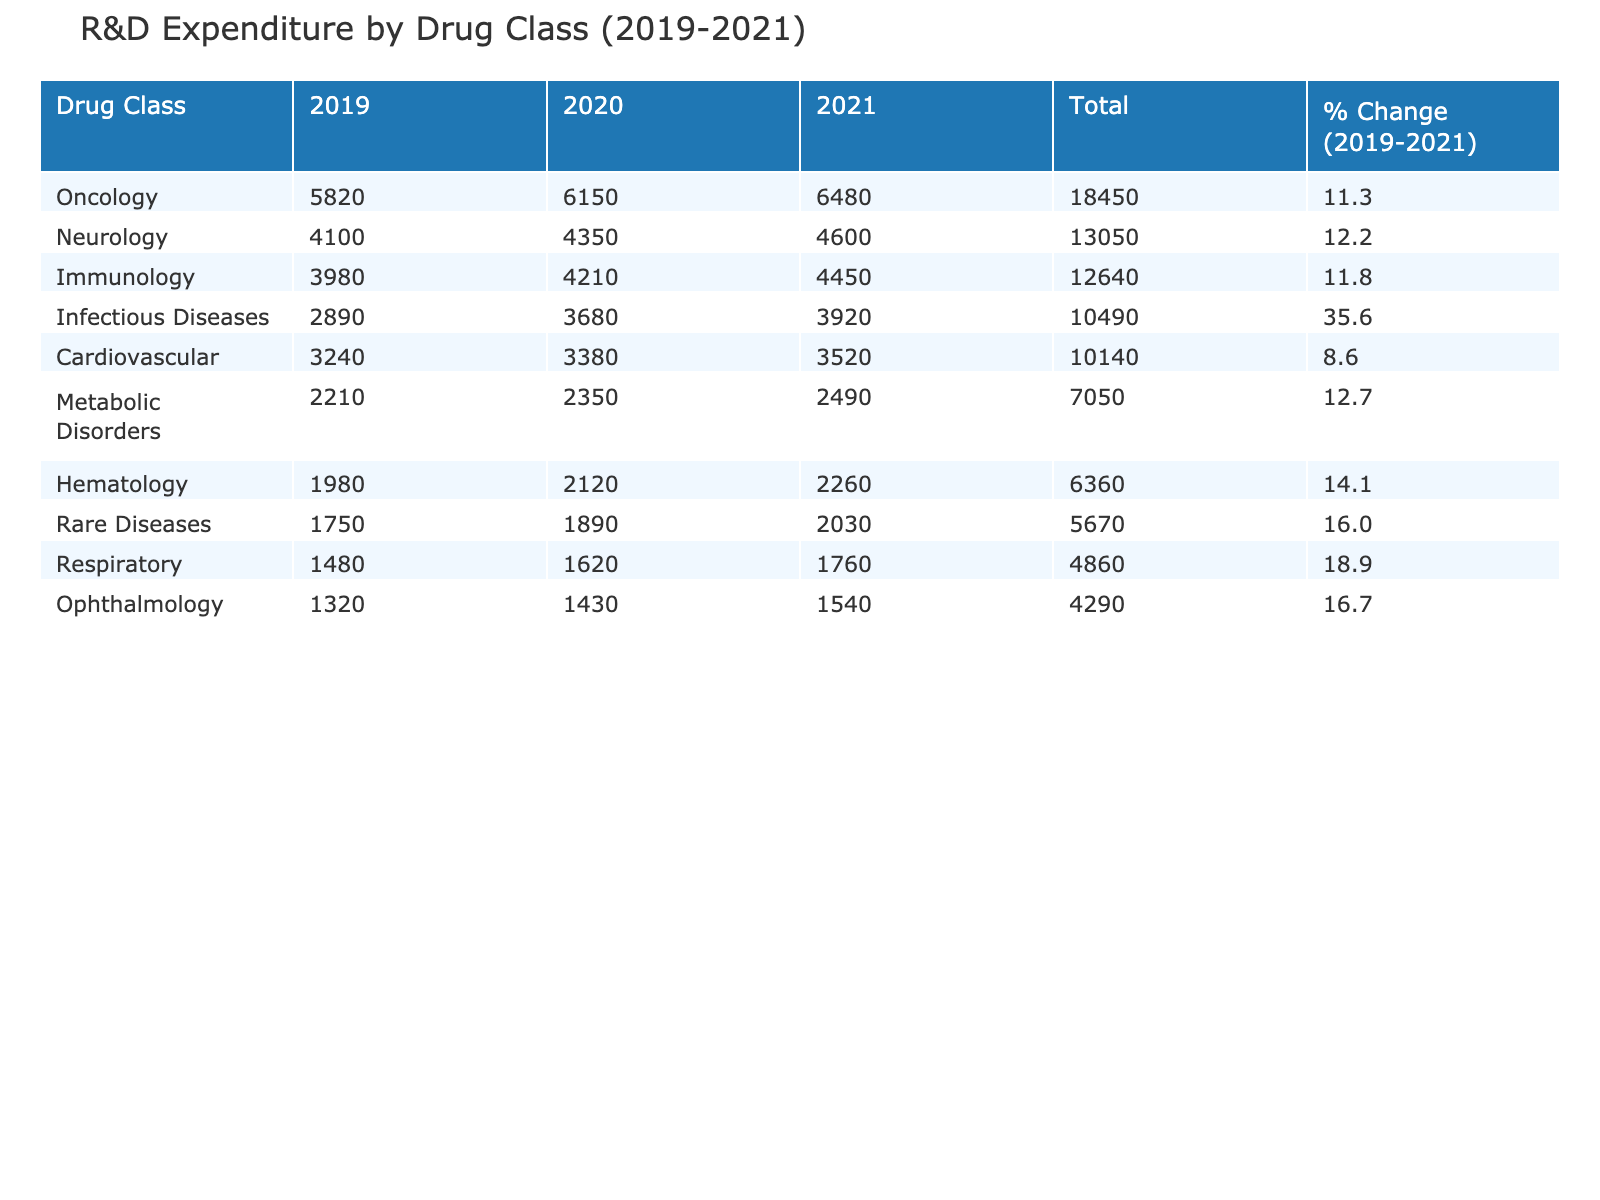What is the R&D expenditure for Oncology in 2021? The table shows that the R&D expenditure for Oncology in 2021 is listed under the year 2021 in the Oncology row. The corresponding value is 6480 million USD.
Answer: 6480 million USD Which drug class had the highest R&D expenditure in 2019? By examining the 2019 column, I can see that Oncology has the highest R&D expenditure of 5820 million USD, more than any other drug class listed in that year.
Answer: Oncology What is the total R&D expenditure for Cardiovascular from 2019 to 2021? To find the total R&D expenditure for Cardiovascular, I add the values from all three years: 3240 + 3380 + 3520 = 10140 million USD.
Answer: 10140 million USD What was the percentage change in R&D expenditure for Neurology from 2019 to 2021? I look at the Neurology row for the years 2019 and 2021, which are 4100 million USD and 4600 million USD, respectively. The percentage change is calculated as ((4600 - 4100) / 4100) * 100 = 12.2%.
Answer: 12.2% Did R&D expenditure for Infectious Diseases increase every year from 2019 to 2021? To answer this, I compare the values for each year: 2890 (2019), 3680 (2020), and 3920 (2021). Since each subsequent year shows an increase compared to the previous year, the statement is true.
Answer: Yes What is the average R&D expenditure for Rare Diseases over the three years? The total R&D expenditure for Rare Diseases is 1750 + 1890 + 2030 = 5670 million USD. To find the average, I divide by 3: 5670 / 3 = 1890 million USD.
Answer: 1890 million USD Which drug class had the lowest total R&D expenditure from 2019 to 2021? I calculate the total R&D expenditure for each drug class. The drug class with the lowest total is Respiratory, with a total of 4860 million USD, based on its expenditures across three years.
Answer: Respiratory What is the difference in total R&D expenditure between Oncology and Immunology? The total for Oncology is 18450 million USD (5820 + 6150 + 6480) and for Immunology is 12640 million USD (3980 + 4210 + 4450). The difference is 18450 - 12640 = 5800 million USD.
Answer: 5800 million USD Is the R&D expenditure for Metabolic Disorders higher in 2021 than in 2019? Looking at the expenditures, Metabolic Disorders had 2210 million USD in 2019 and 2490 million USD in 2021. Since 2490 is greater than 2210, the answer is yes.
Answer: Yes Calculate the total R&D expenditure across all drug classes for the year 2020. I add the R&D expenditures for all drug classes in 2020: 6150 + 3380 + 4350 + 4210 + 3680 + 1890 + 1620 + 2350 + 2120 + 1430 = 24150 million USD.
Answer: 24150 million USD 